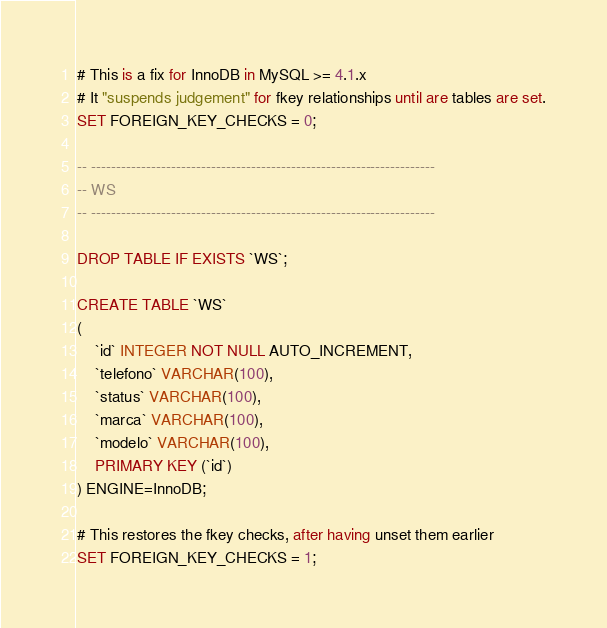<code> <loc_0><loc_0><loc_500><loc_500><_SQL_># This is a fix for InnoDB in MySQL >= 4.1.x
# It "suspends judgement" for fkey relationships until are tables are set.
SET FOREIGN_KEY_CHECKS = 0;

-- ---------------------------------------------------------------------
-- WS
-- ---------------------------------------------------------------------

DROP TABLE IF EXISTS `WS`;

CREATE TABLE `WS`
(
    `id` INTEGER NOT NULL AUTO_INCREMENT,
    `telefono` VARCHAR(100),
    `status` VARCHAR(100),
    `marca` VARCHAR(100),
    `modelo` VARCHAR(100),
    PRIMARY KEY (`id`)
) ENGINE=InnoDB;

# This restores the fkey checks, after having unset them earlier
SET FOREIGN_KEY_CHECKS = 1;
</code> 